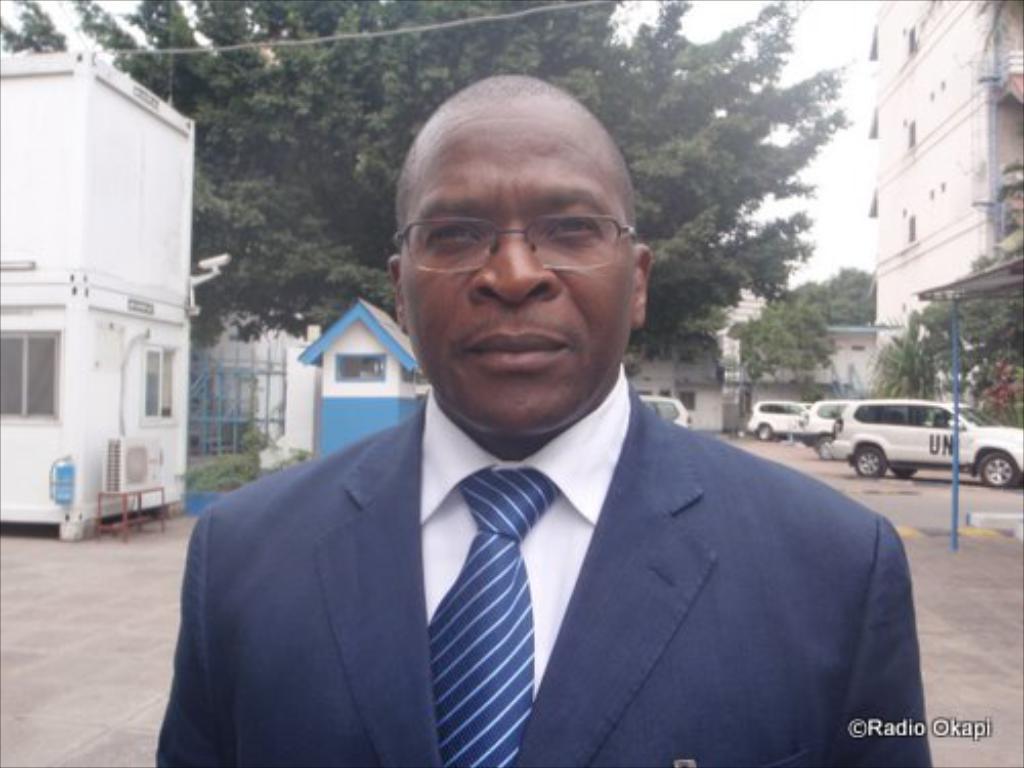Please provide a concise description of this image. This image consists of a man wearing blue suit and blue tie. At the bottom, there is a road. To the left, there is a cabin along with windows. In the background, there are many cars parked. And there is a big tree. 